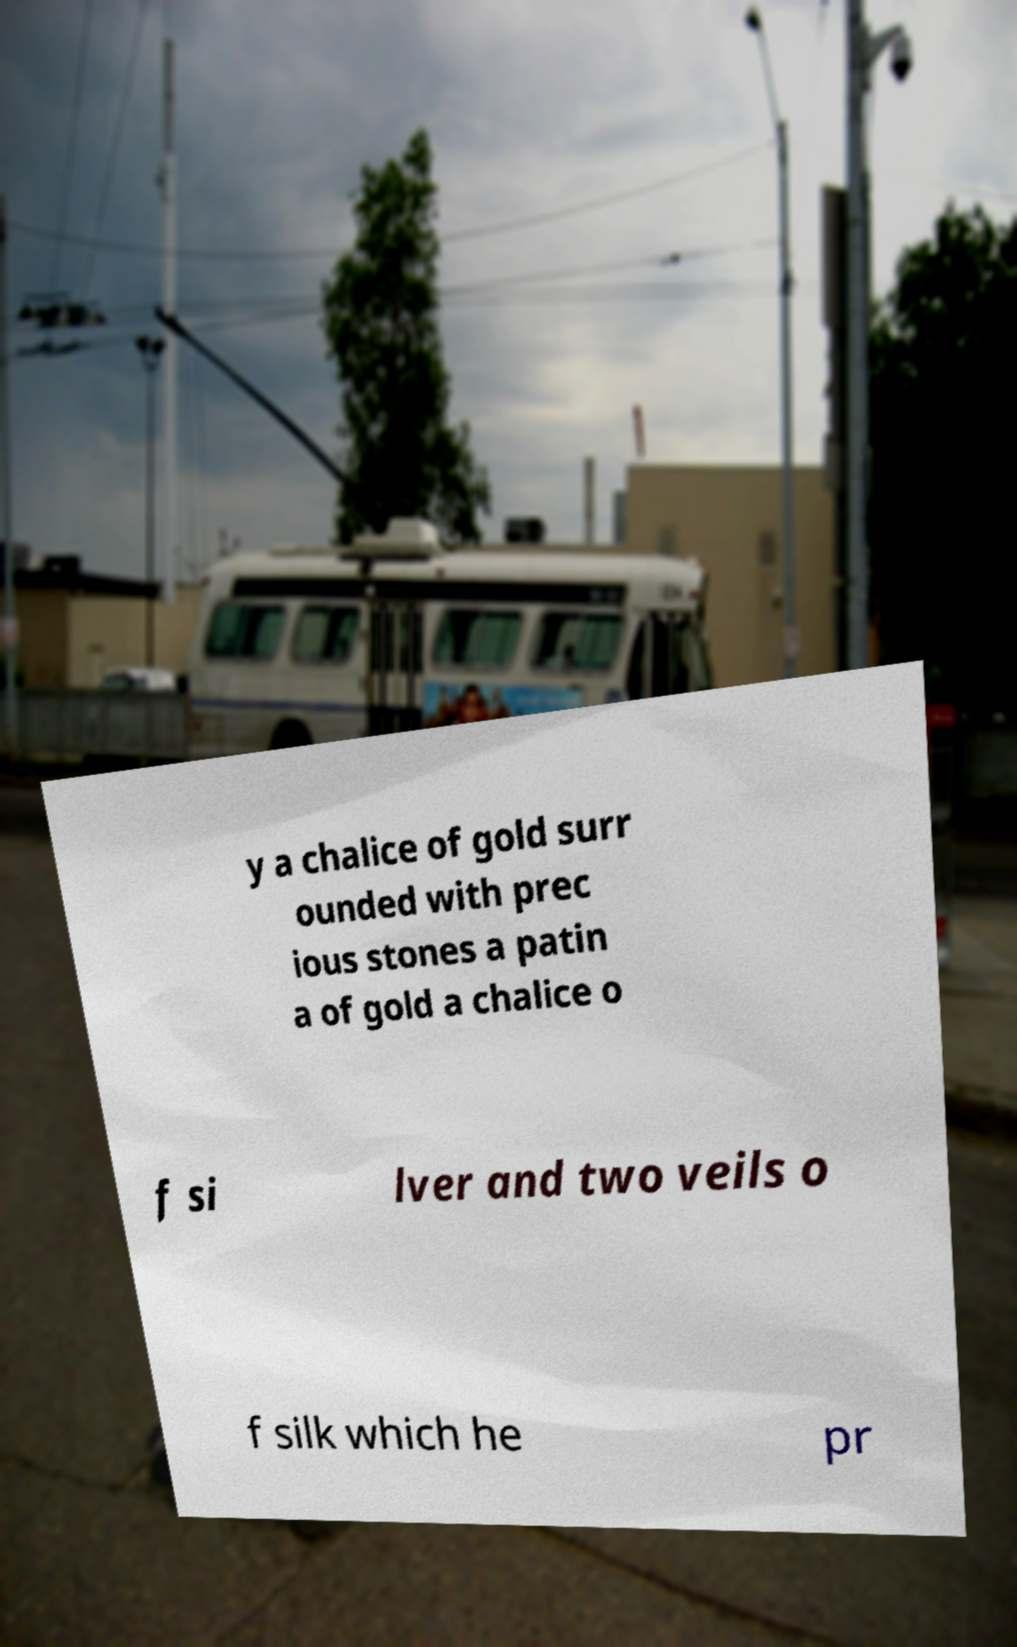Could you assist in decoding the text presented in this image and type it out clearly? y a chalice of gold surr ounded with prec ious stones a patin a of gold a chalice o f si lver and two veils o f silk which he pr 